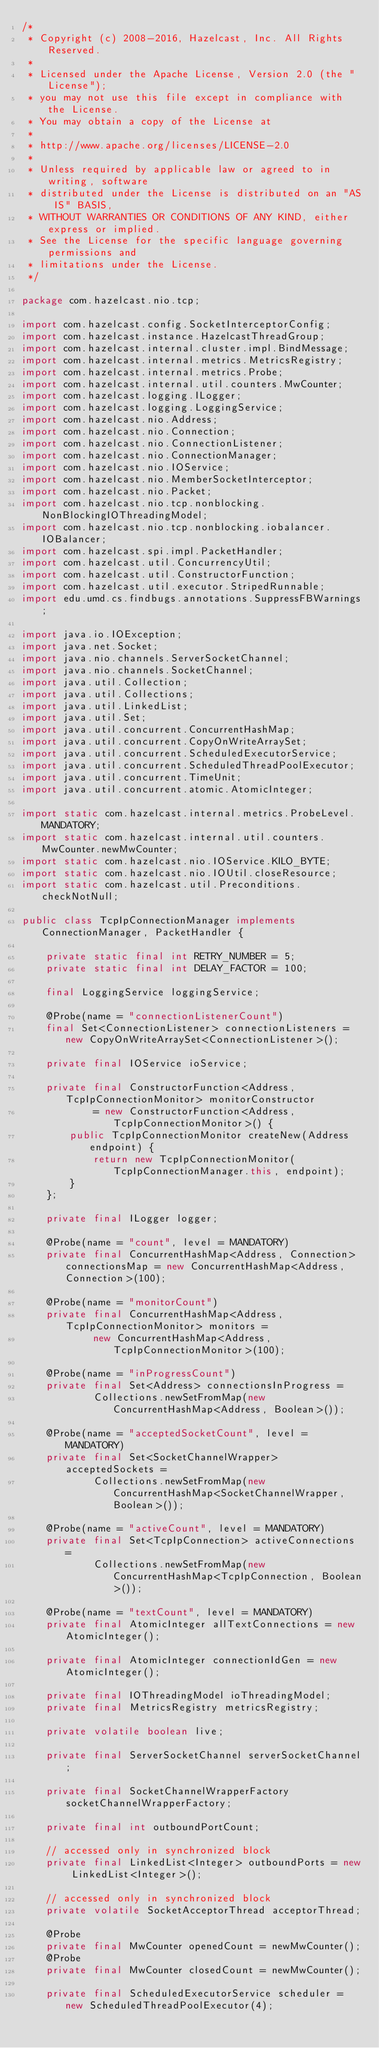Convert code to text. <code><loc_0><loc_0><loc_500><loc_500><_Java_>/*
 * Copyright (c) 2008-2016, Hazelcast, Inc. All Rights Reserved.
 *
 * Licensed under the Apache License, Version 2.0 (the "License");
 * you may not use this file except in compliance with the License.
 * You may obtain a copy of the License at
 *
 * http://www.apache.org/licenses/LICENSE-2.0
 *
 * Unless required by applicable law or agreed to in writing, software
 * distributed under the License is distributed on an "AS IS" BASIS,
 * WITHOUT WARRANTIES OR CONDITIONS OF ANY KIND, either express or implied.
 * See the License for the specific language governing permissions and
 * limitations under the License.
 */

package com.hazelcast.nio.tcp;

import com.hazelcast.config.SocketInterceptorConfig;
import com.hazelcast.instance.HazelcastThreadGroup;
import com.hazelcast.internal.cluster.impl.BindMessage;
import com.hazelcast.internal.metrics.MetricsRegistry;
import com.hazelcast.internal.metrics.Probe;
import com.hazelcast.internal.util.counters.MwCounter;
import com.hazelcast.logging.ILogger;
import com.hazelcast.logging.LoggingService;
import com.hazelcast.nio.Address;
import com.hazelcast.nio.Connection;
import com.hazelcast.nio.ConnectionListener;
import com.hazelcast.nio.ConnectionManager;
import com.hazelcast.nio.IOService;
import com.hazelcast.nio.MemberSocketInterceptor;
import com.hazelcast.nio.Packet;
import com.hazelcast.nio.tcp.nonblocking.NonBlockingIOThreadingModel;
import com.hazelcast.nio.tcp.nonblocking.iobalancer.IOBalancer;
import com.hazelcast.spi.impl.PacketHandler;
import com.hazelcast.util.ConcurrencyUtil;
import com.hazelcast.util.ConstructorFunction;
import com.hazelcast.util.executor.StripedRunnable;
import edu.umd.cs.findbugs.annotations.SuppressFBWarnings;

import java.io.IOException;
import java.net.Socket;
import java.nio.channels.ServerSocketChannel;
import java.nio.channels.SocketChannel;
import java.util.Collection;
import java.util.Collections;
import java.util.LinkedList;
import java.util.Set;
import java.util.concurrent.ConcurrentHashMap;
import java.util.concurrent.CopyOnWriteArraySet;
import java.util.concurrent.ScheduledExecutorService;
import java.util.concurrent.ScheduledThreadPoolExecutor;
import java.util.concurrent.TimeUnit;
import java.util.concurrent.atomic.AtomicInteger;

import static com.hazelcast.internal.metrics.ProbeLevel.MANDATORY;
import static com.hazelcast.internal.util.counters.MwCounter.newMwCounter;
import static com.hazelcast.nio.IOService.KILO_BYTE;
import static com.hazelcast.nio.IOUtil.closeResource;
import static com.hazelcast.util.Preconditions.checkNotNull;

public class TcpIpConnectionManager implements ConnectionManager, PacketHandler {

    private static final int RETRY_NUMBER = 5;
    private static final int DELAY_FACTOR = 100;

    final LoggingService loggingService;

    @Probe(name = "connectionListenerCount")
    final Set<ConnectionListener> connectionListeners = new CopyOnWriteArraySet<ConnectionListener>();

    private final IOService ioService;

    private final ConstructorFunction<Address, TcpIpConnectionMonitor> monitorConstructor
            = new ConstructorFunction<Address, TcpIpConnectionMonitor>() {
        public TcpIpConnectionMonitor createNew(Address endpoint) {
            return new TcpIpConnectionMonitor(TcpIpConnectionManager.this, endpoint);
        }
    };

    private final ILogger logger;

    @Probe(name = "count", level = MANDATORY)
    private final ConcurrentHashMap<Address, Connection> connectionsMap = new ConcurrentHashMap<Address, Connection>(100);

    @Probe(name = "monitorCount")
    private final ConcurrentHashMap<Address, TcpIpConnectionMonitor> monitors =
            new ConcurrentHashMap<Address, TcpIpConnectionMonitor>(100);

    @Probe(name = "inProgressCount")
    private final Set<Address> connectionsInProgress =
            Collections.newSetFromMap(new ConcurrentHashMap<Address, Boolean>());

    @Probe(name = "acceptedSocketCount", level = MANDATORY)
    private final Set<SocketChannelWrapper> acceptedSockets =
            Collections.newSetFromMap(new ConcurrentHashMap<SocketChannelWrapper, Boolean>());

    @Probe(name = "activeCount", level = MANDATORY)
    private final Set<TcpIpConnection> activeConnections =
            Collections.newSetFromMap(new ConcurrentHashMap<TcpIpConnection, Boolean>());

    @Probe(name = "textCount", level = MANDATORY)
    private final AtomicInteger allTextConnections = new AtomicInteger();

    private final AtomicInteger connectionIdGen = new AtomicInteger();

    private final IOThreadingModel ioThreadingModel;
    private final MetricsRegistry metricsRegistry;

    private volatile boolean live;

    private final ServerSocketChannel serverSocketChannel;

    private final SocketChannelWrapperFactory socketChannelWrapperFactory;

    private final int outboundPortCount;

    // accessed only in synchronized block
    private final LinkedList<Integer> outboundPorts = new LinkedList<Integer>();

    // accessed only in synchronized block
    private volatile SocketAcceptorThread acceptorThread;

    @Probe
    private final MwCounter openedCount = newMwCounter();
    @Probe
    private final MwCounter closedCount = newMwCounter();

    private final ScheduledExecutorService scheduler = new ScheduledThreadPoolExecutor(4);
</code> 